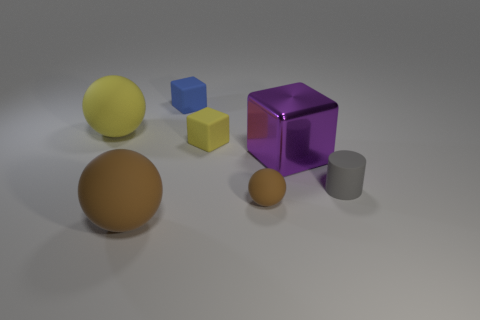What is the material of the big thing that is on the right side of the small blue matte thing?
Make the answer very short. Metal. There is a gray thing that is the same size as the blue matte block; what is its shape?
Give a very brief answer. Cylinder. Are there any gray things that have the same shape as the small brown matte thing?
Your response must be concise. No. Is the large cube made of the same material as the big sphere behind the gray cylinder?
Give a very brief answer. No. What is the big object to the right of the large ball that is in front of the metallic block made of?
Your answer should be compact. Metal. Is the number of tiny yellow objects that are left of the metallic object greater than the number of yellow cylinders?
Provide a succinct answer. Yes. Are there any big cyan metal cubes?
Offer a terse response. No. There is a small rubber object that is on the right side of the small brown object; what is its color?
Provide a succinct answer. Gray. What material is the purple block that is the same size as the yellow ball?
Offer a terse response. Metal. What number of other objects are the same material as the yellow block?
Your answer should be very brief. 5. 